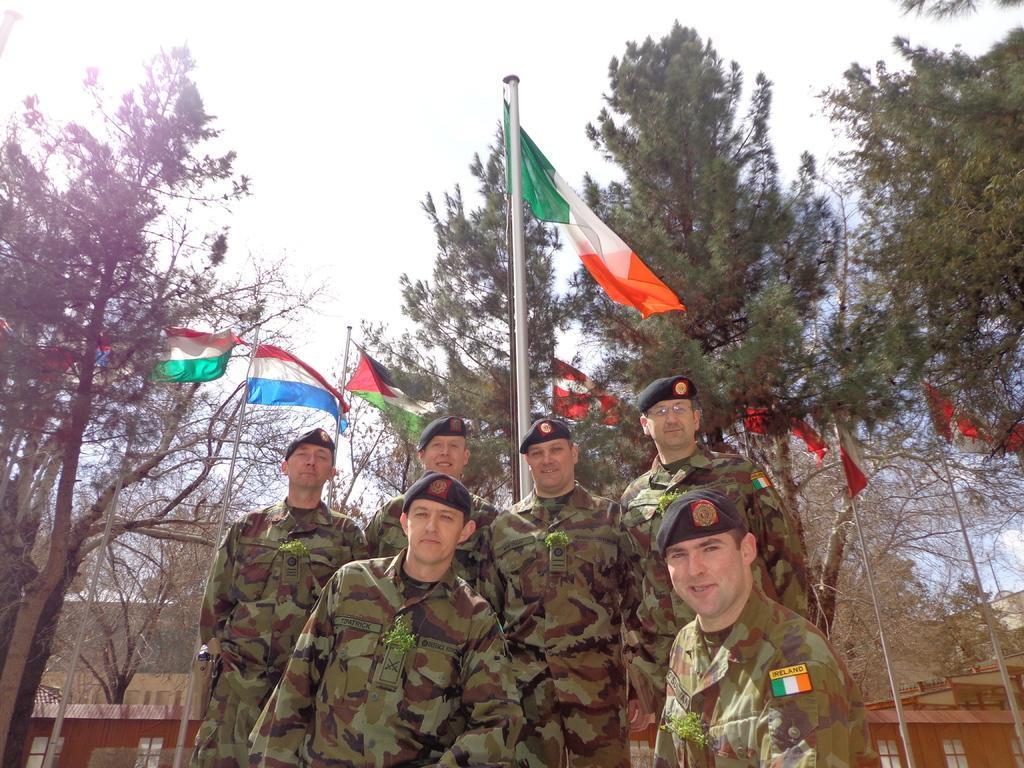What are the men in the image wearing on their heads? The men are wearing black color caps. What color are the dresses worn by the men in the image? The men are wearing green color dresses. What can be seen in the middle of the image? There is a flag in the middle of the image. What type of vegetation is visible at the back side of the image? There are green color trees at the back side of the image. What type of fruit is being distributed among the men in the image? There is no fruit being distributed among the men in the image. What type of soda is being served to the men in the image? There is no soda present in the image. 